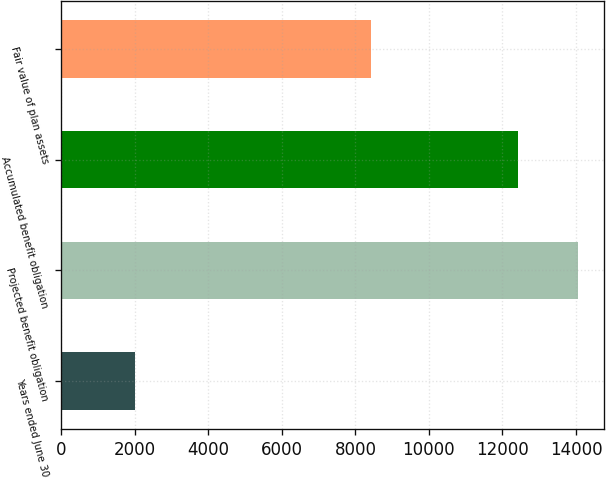Convert chart to OTSL. <chart><loc_0><loc_0><loc_500><loc_500><bar_chart><fcel>Years ended June 30<fcel>Projected benefit obligation<fcel>Accumulated benefit obligation<fcel>Fair value of plan assets<nl><fcel>2015<fcel>14057<fcel>12419<fcel>8435<nl></chart> 